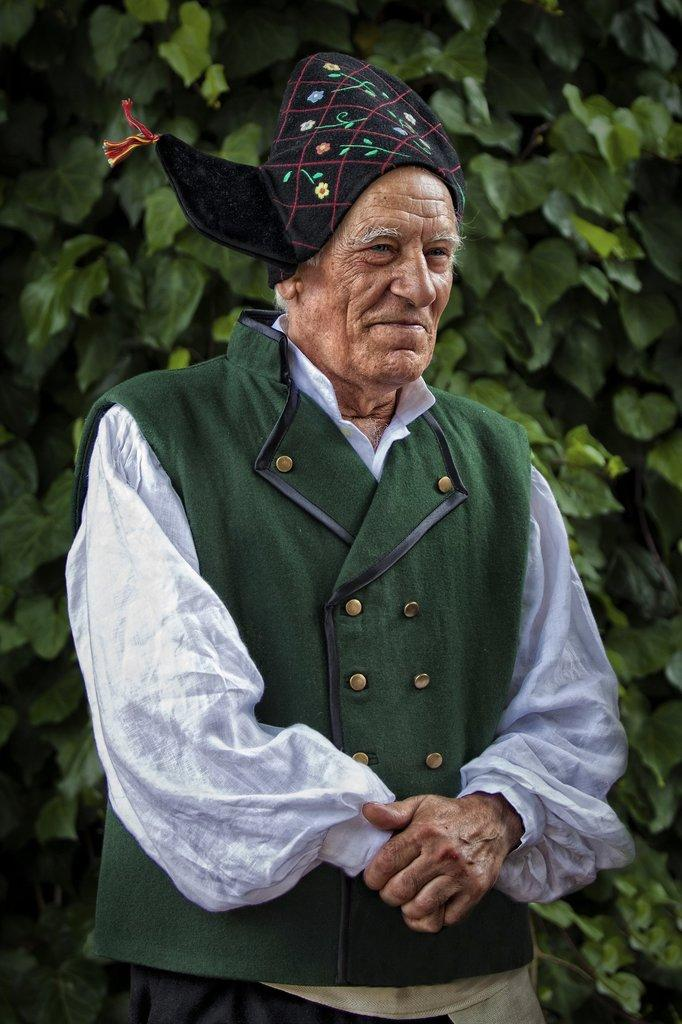What is the main subject of the image? There is a man standing in the image. What can be seen in the background of the image? There are leaves in the background of the image. What type of teeth can be seen in the image? There are no teeth visible in the image; it features a man standing with leaves in the background. 